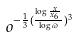<formula> <loc_0><loc_0><loc_500><loc_500>o ^ { - \frac { 1 } { 3 } ( \frac { \log \frac { x } { x _ { 6 } } } { \log \varpi } ) ^ { 3 } }</formula> 